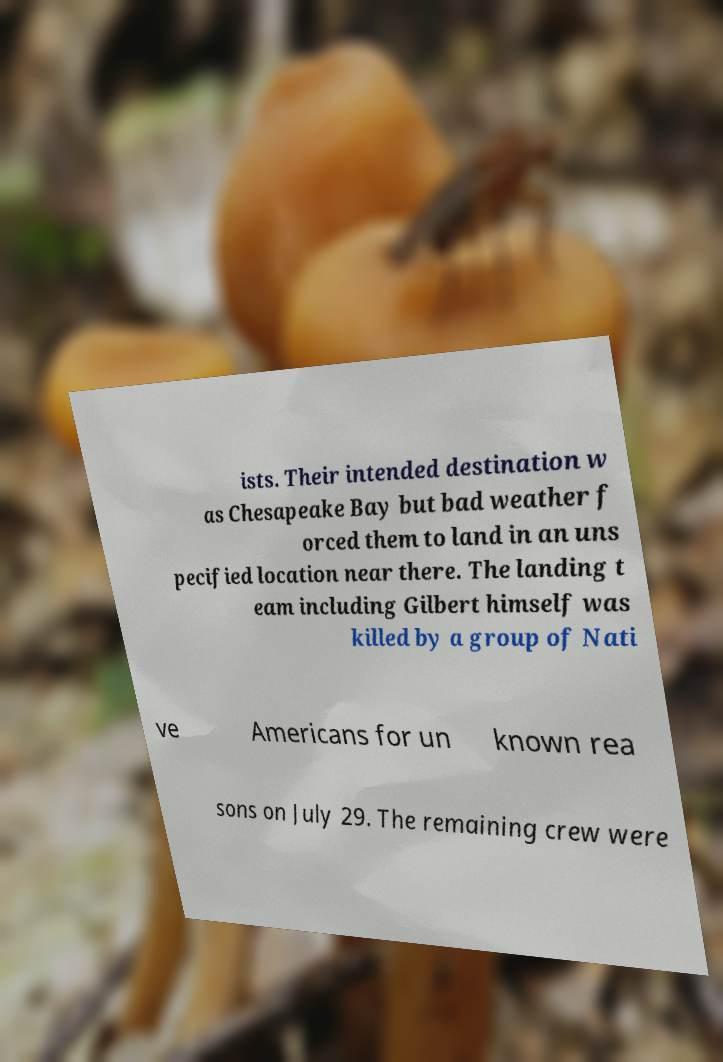Could you assist in decoding the text presented in this image and type it out clearly? ists. Their intended destination w as Chesapeake Bay but bad weather f orced them to land in an uns pecified location near there. The landing t eam including Gilbert himself was killed by a group of Nati ve Americans for un known rea sons on July 29. The remaining crew were 